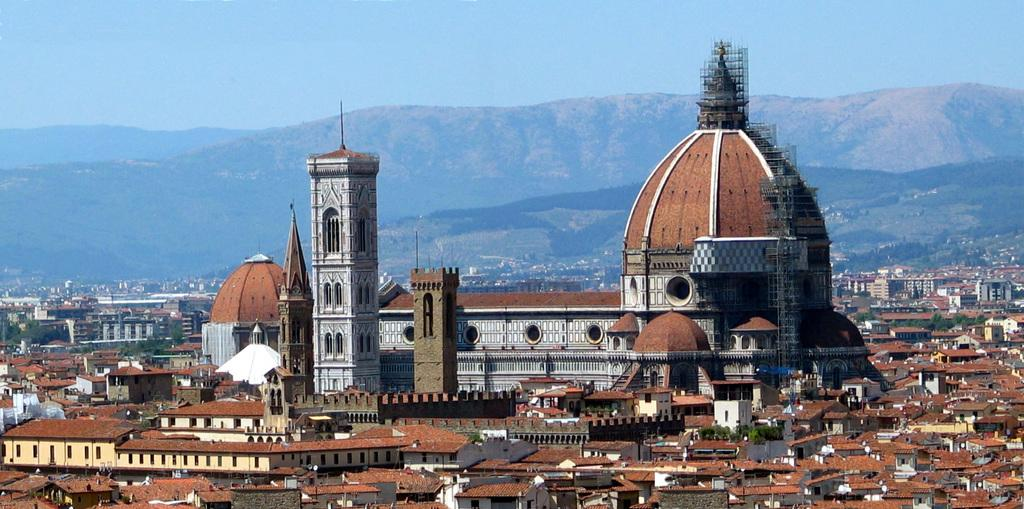What type of structures can be seen in the image? There are buildings in the image. What natural elements are present in the image? There are trees and hills in the image. What is visible in the background of the image? The sky is visible in the background of the image. What type of creature is using a sponge to clean the steel surface in the image? There is no creature, sponge, or steel surface present in the image. 